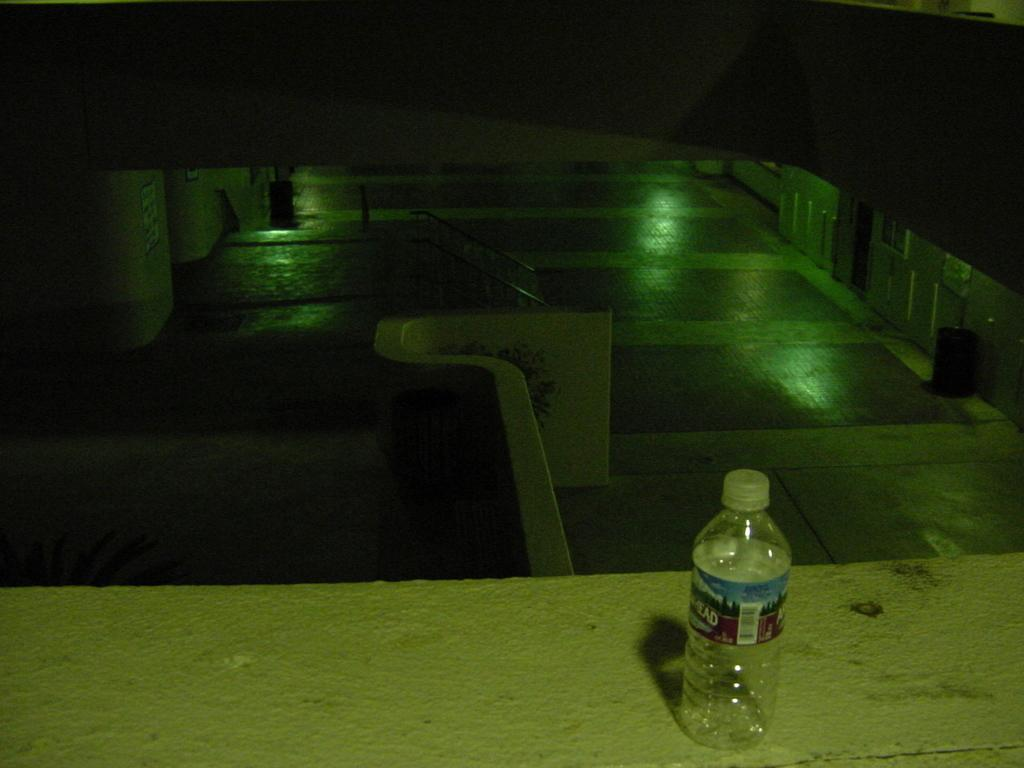What object is visible in the image that is typically used for holding liquids? There is an empty water bottle in the image. Where is the water bottle located in the image? The water bottle is placed on a barrier wall. Who is the creator of the sand visible in the image? There is no sand visible in the image, so it is not possible to determine the creator. 